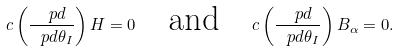<formula> <loc_0><loc_0><loc_500><loc_500>\L c \left ( \frac { \ p d } { \ p d \theta _ { I } } \right ) H = 0 \quad \text {and} \quad \L c \left ( \frac { \ p d } { \ p d \theta _ { I } } \right ) B _ { \alpha } = 0 .</formula> 